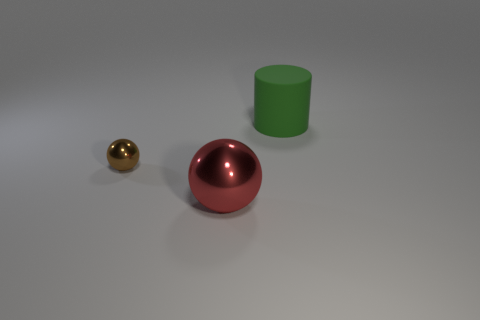Add 2 large brown metal spheres. How many objects exist? 5 Subtract all red balls. How many balls are left? 1 Subtract 1 balls. How many balls are left? 1 Add 2 brown objects. How many brown objects exist? 3 Subtract 0 purple blocks. How many objects are left? 3 Subtract all cylinders. How many objects are left? 2 Subtract all gray balls. Subtract all yellow cylinders. How many balls are left? 2 Subtract all red objects. Subtract all green cylinders. How many objects are left? 1 Add 2 small brown shiny spheres. How many small brown shiny spheres are left? 3 